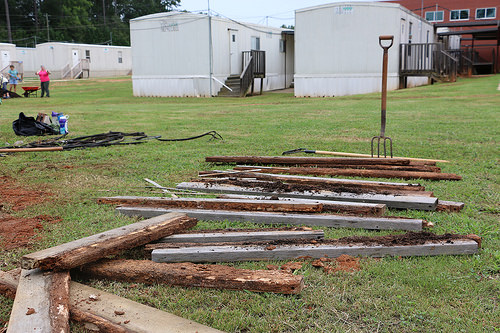<image>
Is the pitchfork on the grass? Yes. Looking at the image, I can see the pitchfork is positioned on top of the grass, with the grass providing support. Is the pitchfork in front of the steps? Yes. The pitchfork is positioned in front of the steps, appearing closer to the camera viewpoint. 